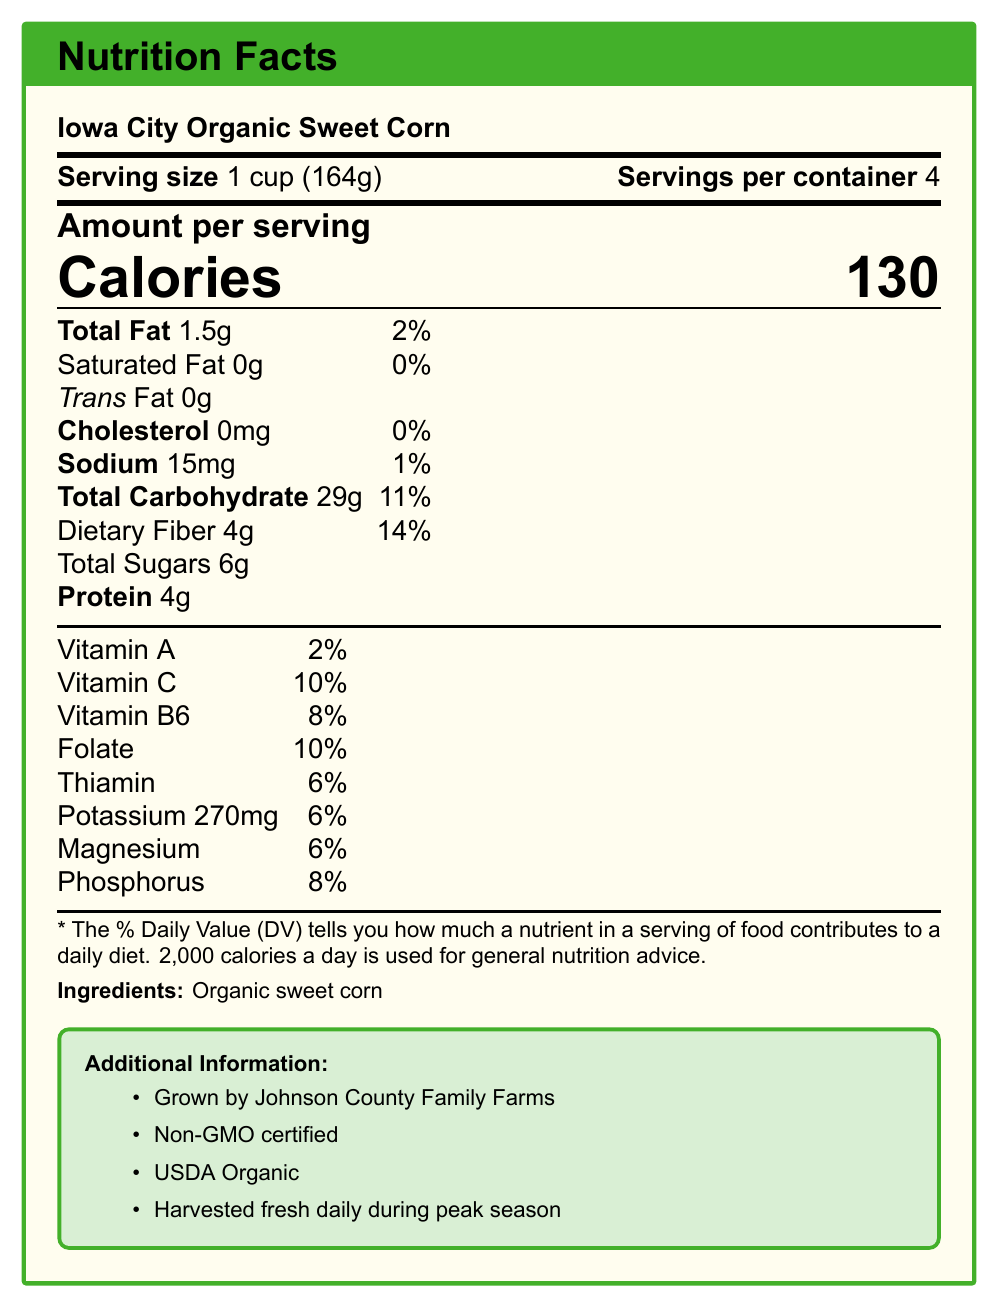What is the serving size for Iowa City Organic Sweet Corn? The serving size is explicitly mentioned as "1 cup (164g)" in the document.
Answer: 1 cup (164g) How many servings are there per container of Iowa City Organic Sweet Corn? The document states that there are 4 servings per container.
Answer: 4 How much dietary fiber is in one serving of this product? The nutrition facts list dietary fiber as 4g per serving.
Answer: 4g What percentage of the Daily Value of dietary fiber does one serving of this sweet corn provide? The document specifies that one serving provides 14% of the Daily Value of dietary fiber.
Answer: 14% What is the amount of vitamin C per serving in terms of the Daily Value percentage? The document mentions that vitamin C is 10% of the Daily Value per serving.
Answer: 10% Which farm grows the Iowa City Organic Sweet Corn? A. Johnson County Family Farms B. Green Valley Farms C. Iowa Harvest Co. The document lists "Grown by Johnson County Family Farms" as part of the additional information.
Answer: A Which of the following is NOT a feature of the Iowa City Organic Sweet Corn? A. Non-GMO certified B. USDA Organic C. Contains high fructose corn syrup The document states the product is Non-GMO certified and USDA Organic. There is no mention of high fructose corn syrup, and the ingredient list only includes "Organic sweet corn".
Answer: C Does the Iowa City Organic Sweet Corn contain any trans fat? The document specifies that the product contains 0g of trans fat.
Answer: No Does this product support local agriculture in Johnson County? The additional information mentions that it is grown by Johnson County Family Farms, which supports local agriculture.
Answer: Yes Summarize the main idea of the document. The document presents detailed nutritional information including fiber and vitamin content, outlines the serving size, and highlights the product's organic certification and local sourcing from Johnson County Family Farms.
Answer: This document provides the nutrition facts, serving information, and additional details for Iowa City Organic Sweet Corn, emphasizing its organic nature, the local farm it supports, and key nutrients such as dietary fiber and vitamins. How many calories are there per serving? The calorie information is clearly mentioned as 130 per serving.
Answer: 130 What is the total carbohydrate content per serving, and what percentage of the Daily Value does it represent? The document lists total carbohydrates as 29g per serving, which represents 11% of the Daily Value.
Answer: 29g, 11% Which vitamins are present in notable quantities in this product? A. Vitamin A, Vitamin B6, Vitamin C B. Vitamin K, Vitamin D, Vitamin E C. Vitamin C, Vitamin B12, Vitamin A The document specifies that it contains Vitamin A (2%), Vitamin B6 (8%), and Vitamin C (10%).
Answer: A How much protein does one serving of this corn contain? The document records the protein content as 4g per serving.
Answer: 4g What is the source of sweet corn in this product? The ingredient list in the document only includes "Organic sweet corn".
Answer: Organic sweet corn What is the economic impact of purchasing this product? The document does not provide specific data on the economic impact of purchasing the product; it only mentions it supports local farmers.
Answer: Not enough information How much sodium is there per serving, and what is the Daily Value percentage? The document lists sodium content as 15mg per serving, which is 1% of the Daily Value.
Answer: 15mg, 1% 